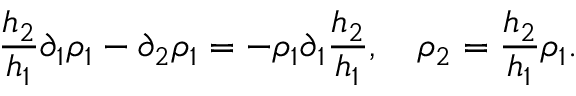Convert formula to latex. <formula><loc_0><loc_0><loc_500><loc_500>\frac { h _ { 2 } } { h _ { 1 } } \partial _ { 1 } \rho _ { 1 } - \partial _ { 2 } \rho _ { 1 } = - \rho _ { 1 } \partial _ { 1 } \frac { h _ { 2 } } { h _ { 1 } } , \quad \rho _ { 2 } = \frac { h _ { 2 } } { h _ { 1 } } \rho _ { 1 } .</formula> 